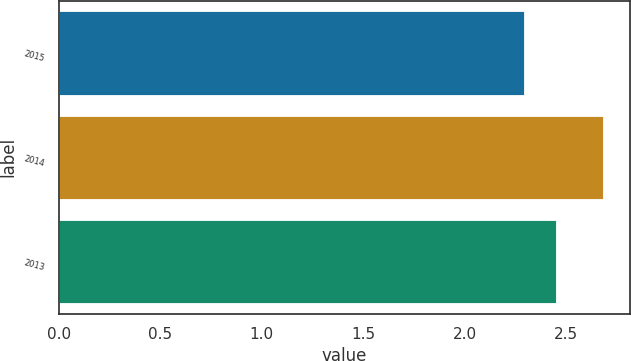Convert chart. <chart><loc_0><loc_0><loc_500><loc_500><bar_chart><fcel>2015<fcel>2014<fcel>2013<nl><fcel>2.29<fcel>2.68<fcel>2.45<nl></chart> 